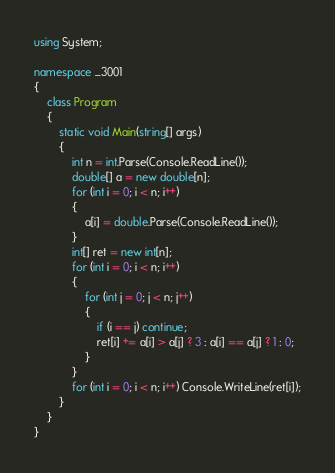<code> <loc_0><loc_0><loc_500><loc_500><_C#_>using System;

namespace _3001
{
    class Program
    {
        static void Main(string[] args)
        {
            int n = int.Parse(Console.ReadLine());
            double[] a = new double[n];
            for (int i = 0; i < n; i++)
            {
                a[i] = double.Parse(Console.ReadLine());
            }
            int[] ret = new int[n];
            for (int i = 0; i < n; i++)
            {
                for (int j = 0; j < n; j++)
                {
                    if (i == j) continue;
                    ret[i] += a[i] > a[j] ? 3 : a[i] == a[j] ? 1 : 0;
                }
            }
            for (int i = 0; i < n; i++) Console.WriteLine(ret[i]);
        }
    }
}</code> 